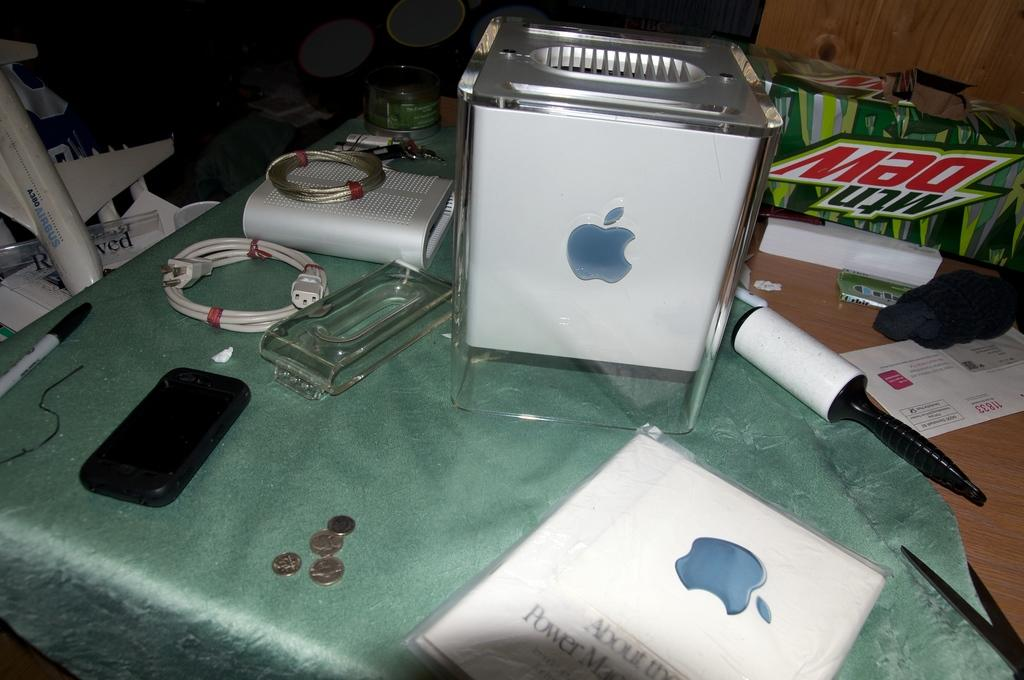<image>
Provide a brief description of the given image. Some of the items on this table include a smart phone, some coins and a pack of Mountain Dew. 